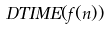<formula> <loc_0><loc_0><loc_500><loc_500>D T I M E ( f ( n ) )</formula> 